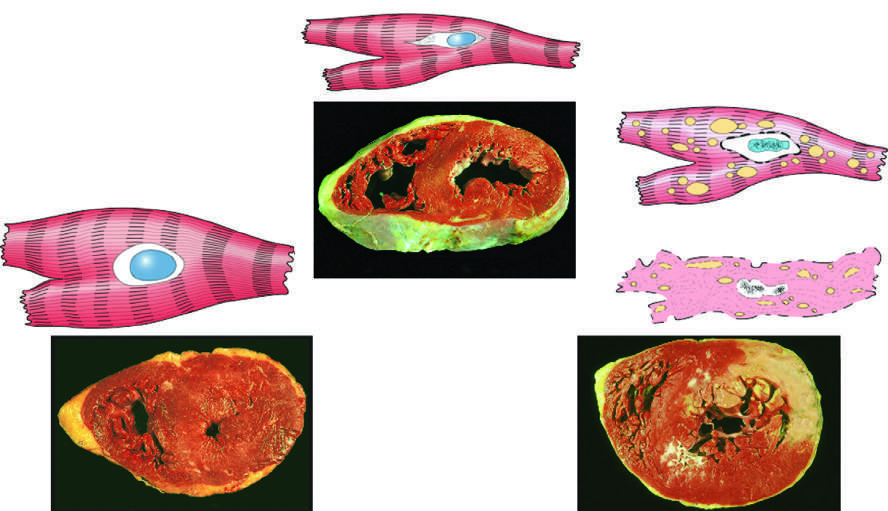what shows functional effects without any gross or light microscopic changes, or reversible changes such as cellular swelling and fatty change?
Answer the question using a single word or phrase. Reversibly injured myocardium 